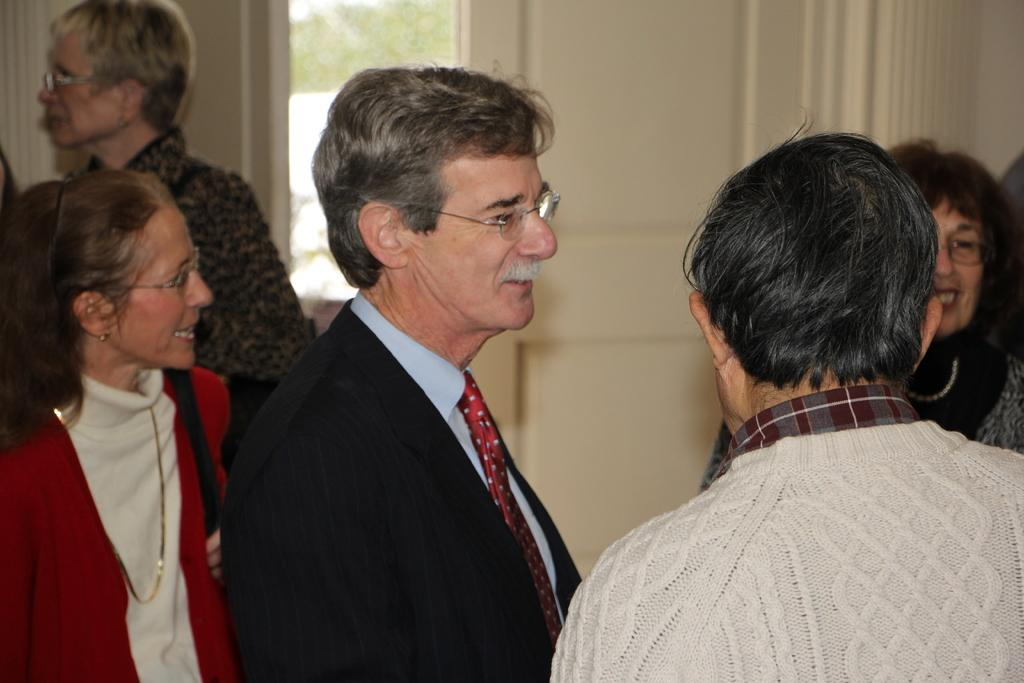How many people are the people are in the image? There are many people in the image. What are the people wearing in the image? The people are wearing clothes and spectacles. Can you describe the woman in the image? The woman is wearing a neck chain and earrings. What is the only architectural feature mentioned in the image? There is the door. How would you describe the background of the image? The background of the image is blurred. What type of furniture can be seen in the image? There is no furniture present in the image. Is there an umbrella being used by any of the people in the image? There is no umbrella visible in the image. 